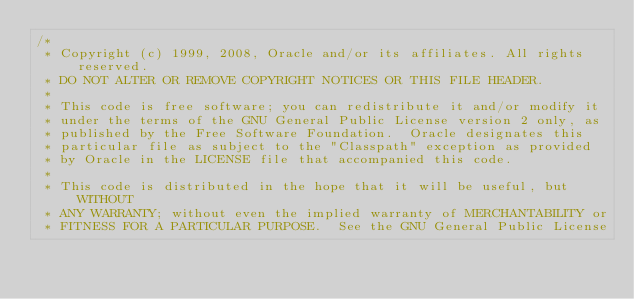Convert code to text. <code><loc_0><loc_0><loc_500><loc_500><_Java_>/*
 * Copyright (c) 1999, 2008, Oracle and/or its affiliates. All rights reserved.
 * DO NOT ALTER OR REMOVE COPYRIGHT NOTICES OR THIS FILE HEADER.
 *
 * This code is free software; you can redistribute it and/or modify it
 * under the terms of the GNU General Public License version 2 only, as
 * published by the Free Software Foundation.  Oracle designates this
 * particular file as subject to the "Classpath" exception as provided
 * by Oracle in the LICENSE file that accompanied this code.
 *
 * This code is distributed in the hope that it will be useful, but WITHOUT
 * ANY WARRANTY; without even the implied warranty of MERCHANTABILITY or
 * FITNESS FOR A PARTICULAR PURPOSE.  See the GNU General Public License</code> 